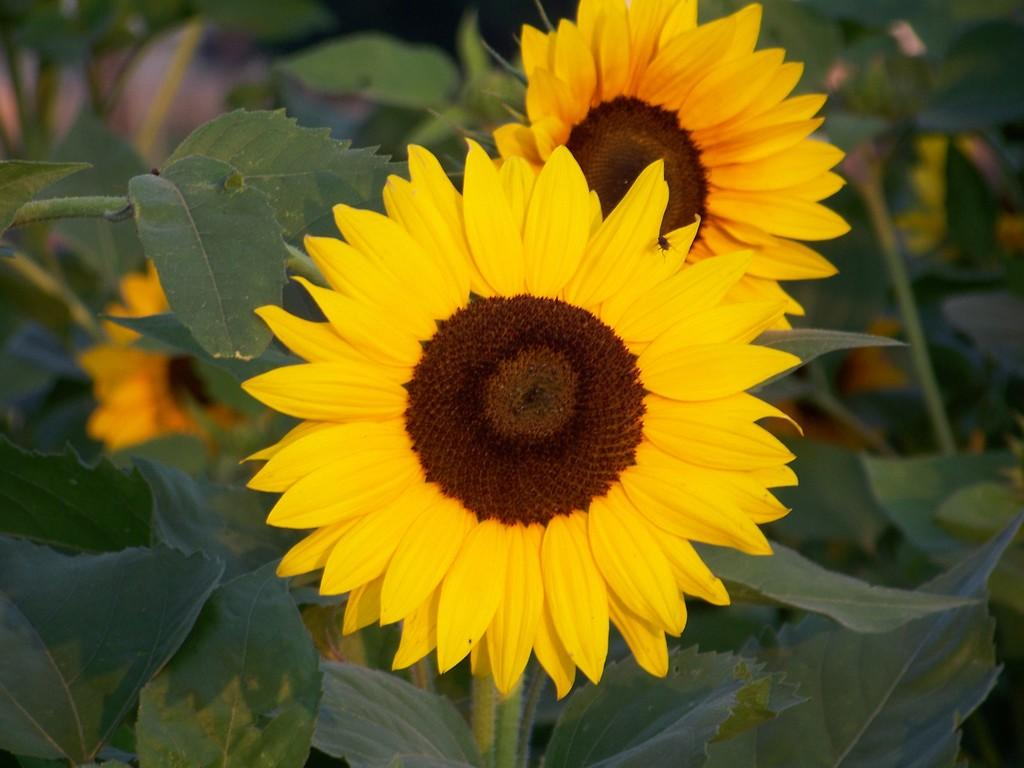What types of plants are in the foreground of the image? There are two sunflowers in the foreground of the image. What can be seen in the background of the image? There are plants and flowers in the background of the image. What type of honey is being produced by the sunflowers in the image? Sunflowers do not produce honey, so there is no honey being produced in the image. 